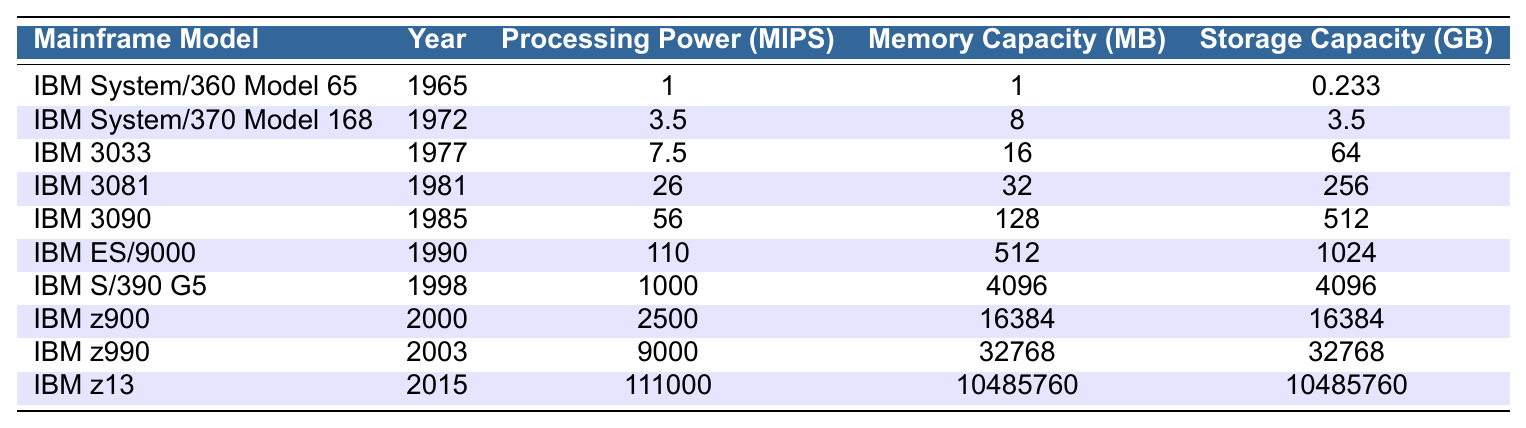What is the processing power of the IBM z13? The table lists the processing power of each mainframe model. For the IBM z13, it is explicitly stated as 111000 MIPS.
Answer: 111000 MIPS Which mainframe model has the highest memory capacity? The table shows the memory capacity for each model. By examining the values, the IBM z13 has the highest memory capacity at 10485760 MB.
Answer: IBM z13 What is the storage capacity difference between the IBM 3033 and the IBM 3090? The storage capacity for IBM 3033 is 64 GB and for IBM 3090 is 512 GB. The difference can be calculated by subtracting 64 from 512, which equals 448 GB.
Answer: 448 GB How many mainframe models were introduced after 1980? The table lists the years of introduction for each mainframe. By counting the models introduced from 1981 onward (IBM 3081, IBM 3090, IBM ES/9000, IBM S/390 G5, IBM z900, IBM z990, and IBM z13), there are 7 such models.
Answer: 7 Is the IBM System/370 Model 168 more powerful than the IBM System/360 Model 65? Comparing their processing power in the table, the IBM System/370 Model 168 has 3.5 MIPS, while the IBM System/360 Model 65 has only 1 MIPS. Therefore, yes, it is more powerful.
Answer: Yes What is the average processing power of mainframes from the year 2000 onwards? The mainframes from 2000 onwards listed in the table are IBM z900 (2500 MIPS), IBM z990 (9000 MIPS), and IBM z13 (111000 MIPS). Their average is calculated by summing them up (2500 + 9000 + 111000 = 127500) and dividing by 3, giving an average of 42500 MIPS.
Answer: 42500 MIPS Which model has a memory capacity less than 100 MB? By inspecting the memory capacity values, both IBM System/360 Model 65 (1 MB) and IBM System/370 Model 168 (8 MB) have memory capacities under 100 MB.
Answer: IBM System/360 Model 65, IBM System/370 Model 168 What percentage increase in processing power is observed from IBM 3090 to IBM z13? The processing power of IBM 3090 is 56 MIPS and of IBM z13 is 111000 MIPS. The increase is 111000 - 56 = 110944 MIPS. To find the percentage increase, divide that increase by the original power: (110944/56) * 100 ≈ 197,000%.
Answer: Approximately 197000% Which mainframe model has a storage capacity greater than 1000 GB? The table lists the storage capacities of all mainframes. Only the IBM z13 has a storage capacity of 10485760 GB, which is significantly greater than 1000 GB.
Answer: IBM z13 What can we deduce about the trend in processing power from 1965 to 2015? By looking at the processing power values chronologically, we see a consistent increase over the years, suggesting that mainframe technology has advanced significantly, culminating in the IBM z13's processing power of 111000 MIPS in 2015.
Answer: Consistent increase in processing power 